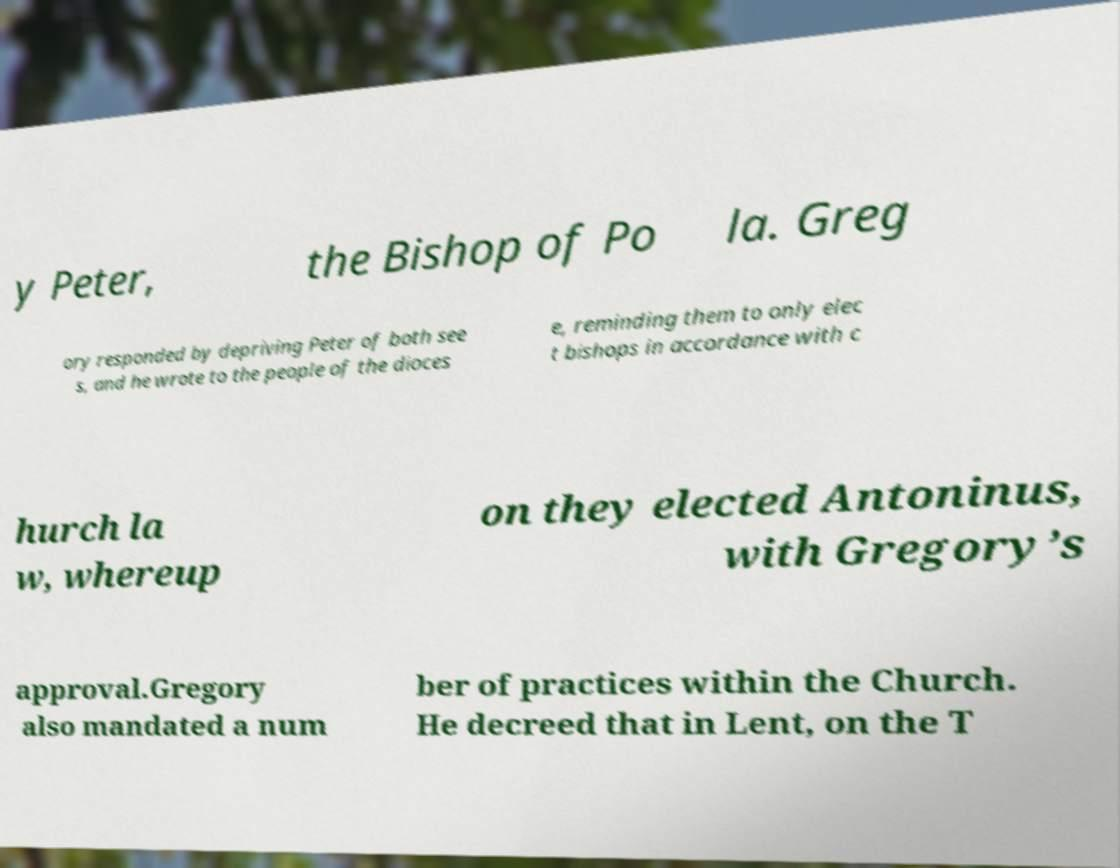There's text embedded in this image that I need extracted. Can you transcribe it verbatim? y Peter, the Bishop of Po la. Greg ory responded by depriving Peter of both see s, and he wrote to the people of the dioces e, reminding them to only elec t bishops in accordance with c hurch la w, whereup on they elected Antoninus, with Gregory’s approval.Gregory also mandated a num ber of practices within the Church. He decreed that in Lent, on the T 